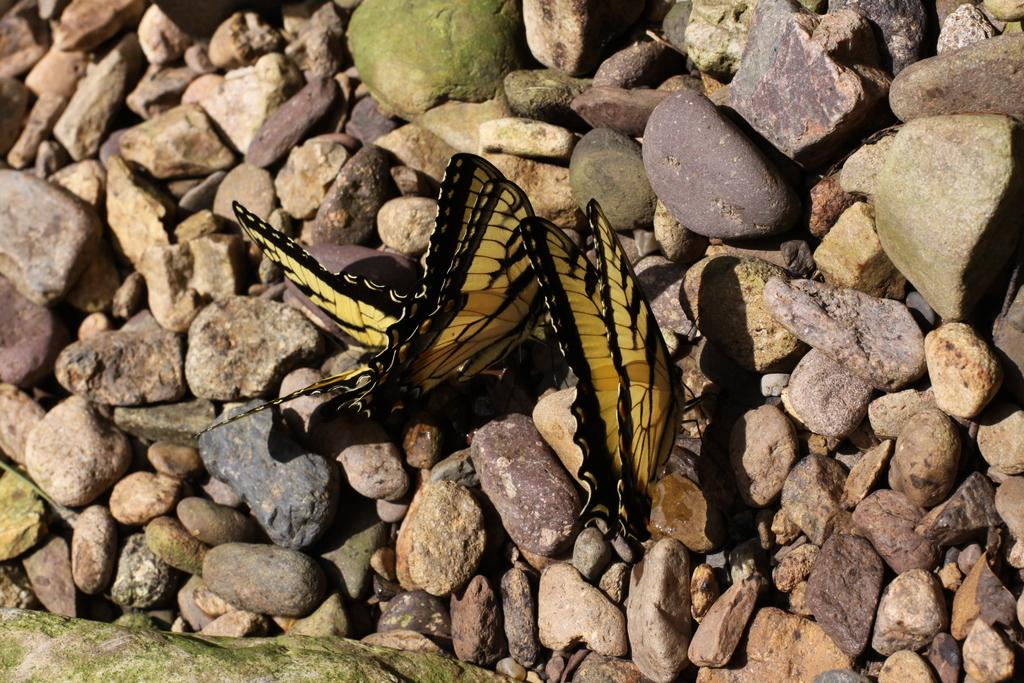What is present on the rocks in the image? There are butterflies on the rocks. What colors can be seen on the butterflies? The butterflies are in yellow and black colors. What type of bubble can be seen floating near the butterflies in the image? There is no bubble present in the image; it features butterflies on rocks. What role does the nose play in the image? There is no reference to a nose in the image, so it cannot be determined what role it might play. 